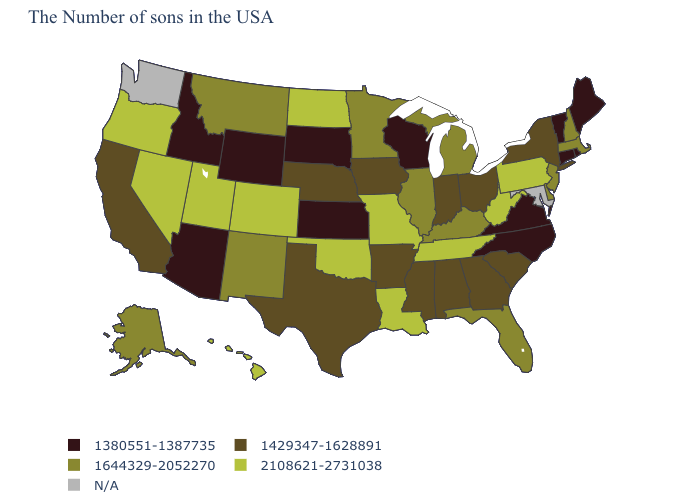Does Nevada have the highest value in the West?
Concise answer only. Yes. What is the value of Ohio?
Be succinct. 1429347-1628891. What is the value of Massachusetts?
Concise answer only. 1644329-2052270. What is the lowest value in the USA?
Answer briefly. 1380551-1387735. Does the first symbol in the legend represent the smallest category?
Answer briefly. Yes. Does Rhode Island have the lowest value in the USA?
Concise answer only. Yes. Does North Carolina have the lowest value in the USA?
Concise answer only. Yes. What is the value of Virginia?
Keep it brief. 1380551-1387735. Which states have the highest value in the USA?
Short answer required. Pennsylvania, West Virginia, Tennessee, Louisiana, Missouri, Oklahoma, North Dakota, Colorado, Utah, Nevada, Oregon, Hawaii. Among the states that border Kansas , which have the lowest value?
Give a very brief answer. Nebraska. Name the states that have a value in the range 1380551-1387735?
Be succinct. Maine, Rhode Island, Vermont, Connecticut, Virginia, North Carolina, Wisconsin, Kansas, South Dakota, Wyoming, Arizona, Idaho. Name the states that have a value in the range N/A?
Be succinct. Maryland, Washington. Does the map have missing data?
Give a very brief answer. Yes. Name the states that have a value in the range N/A?
Be succinct. Maryland, Washington. 